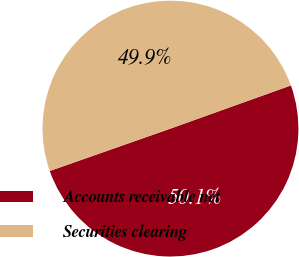<chart> <loc_0><loc_0><loc_500><loc_500><pie_chart><fcel>Accounts receivable net<fcel>Securities clearing<nl><fcel>50.1%<fcel>49.9%<nl></chart> 